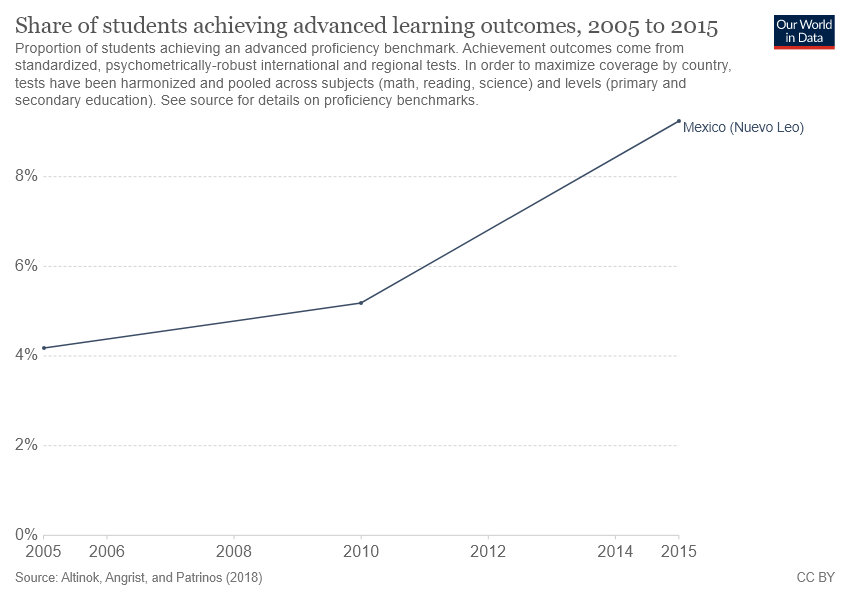Identify some key points in this picture. The line started to experience a significant increase in a period beginning in 2010. The graph shows a country that is Mexico. 